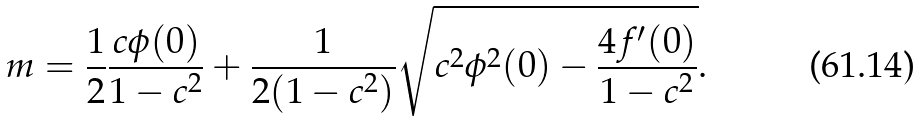Convert formula to latex. <formula><loc_0><loc_0><loc_500><loc_500>m = \frac { 1 } { 2 } \frac { c \phi ( 0 ) } { 1 - c ^ { 2 } } + \frac { 1 } { 2 ( 1 - c ^ { 2 } ) } \sqrt { c ^ { 2 } \phi ^ { 2 } ( 0 ) - \frac { 4 f ^ { \prime } ( 0 ) } { 1 - c ^ { 2 } } } .</formula> 